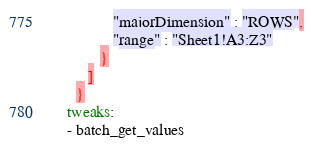Convert code to text. <code><loc_0><loc_0><loc_500><loc_500><_YAML_>               "majorDimension" : "ROWS",
               "range" : "Sheet1!A3:Z3"
            }
         ]
      }
    tweaks:
    - batch_get_values
</code> 